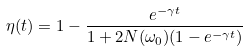Convert formula to latex. <formula><loc_0><loc_0><loc_500><loc_500>\eta ( t ) = 1 - \frac { e ^ { - \gamma t } } { 1 + 2 N ( \omega _ { 0 } ) ( 1 - e ^ { - \gamma t } ) }</formula> 